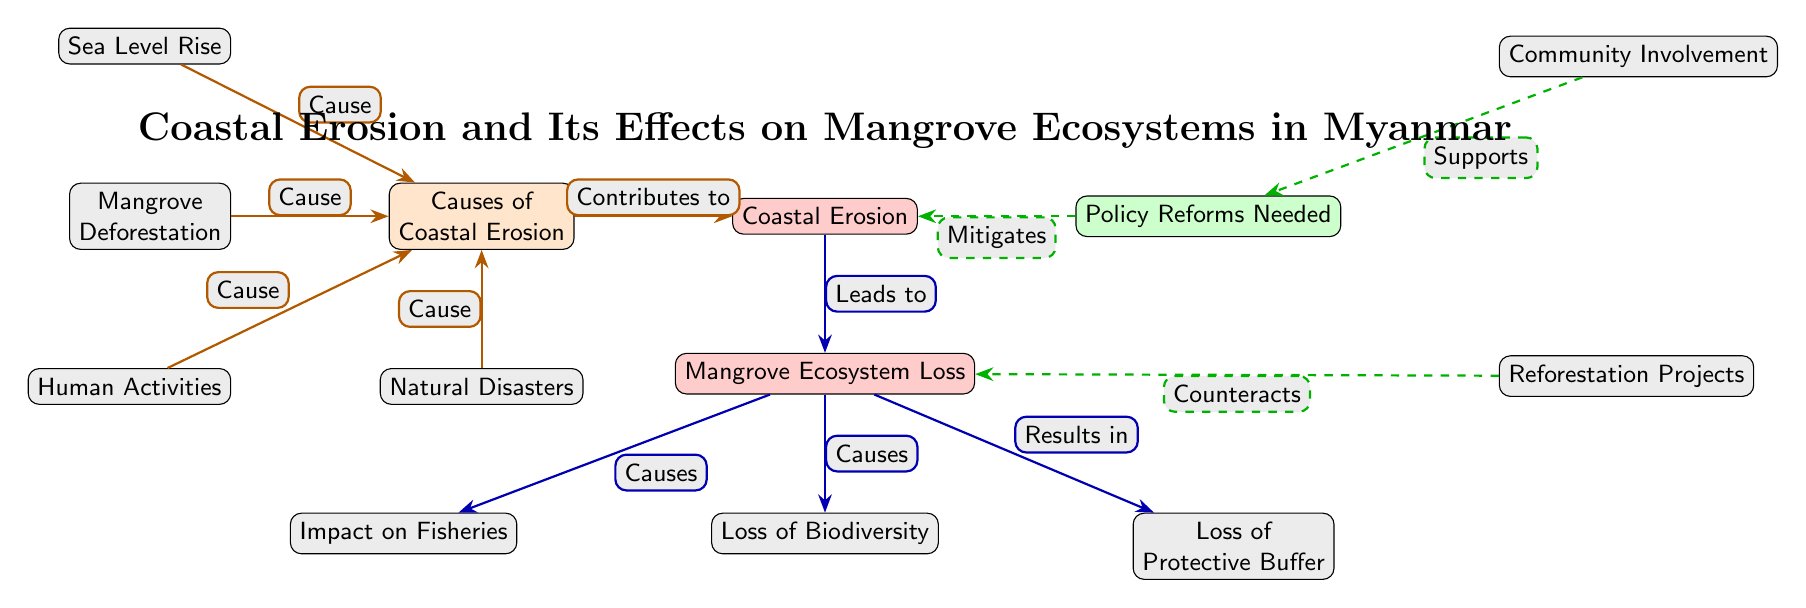What are the main causes of coastal erosion? The main causes of coastal erosion can be found in the left section of the diagram. They are listed as sea level rise, mangrove deforestation, human activities, and natural disasters.
Answer: Sea level rise, mangrove deforestation, human activities, natural disasters What does coastal erosion lead to? The bottom section of the diagram shows the consequences of coastal erosion. It indicates that coastal erosion leads to mangrove ecosystem loss.
Answer: Mangrove Ecosystem Loss How many different causes of coastal erosion are identified in the diagram? By counting the nodes listed under the causes section on the left, there are four distinct causes: sea level rise, mangrove deforestation, human activities, and natural disasters.
Answer: Four What is one of the impacts of mangrove ecosystem loss? The effects of mangrove ecosystem loss are shown in the left section below it. One of those impacts is the impact on fisheries, indicating the loss directly affects fish populations and fishing activities.
Answer: Impact on Fisheries Which node is connected to the mitigation strategies? The right section of the diagram outlines the policy reforms needed along with community involvement and reforestation projects as mitigation strategies. The node 'Policy Reforms Needed' is directly linked to the mitigation efforts for coastal erosion.
Answer: Policy Reforms Needed How does community involvement affect policy reforms? The diagram indicates a supportive relationship where community involvement is linked to the policy reforms needed with a dashed arrow, highlighting that community participation supports and aids the implementation of these reforms.
Answer: Supports What type of relationship exists between mangrove ecosystem loss and loss of biodiversity? Following the effect flow from the mangrove ecosystem loss node, there is a direct cause-effect relationship indicated by the label 'Causes', which highlights that mangrove ecosystem loss contributes to a loss of biodiversity.
Answer: Causes What project type counteracts mangrove ecosystem loss? According to the mitigation section, the reforestation projects node is connected to mangrove ecosystem loss with a label 'Counteracts', indicating that these projects are intended to help restore mangroves and mitigate their loss.
Answer: Reforestation Projects 